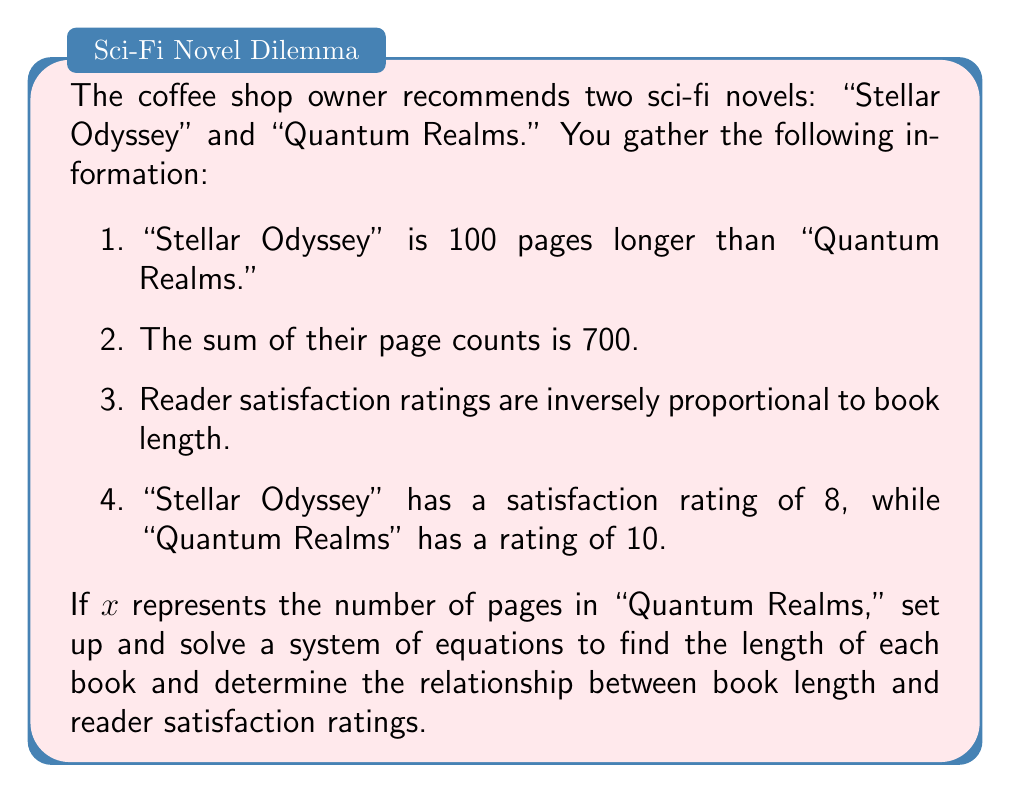Solve this math problem. Let's approach this step-by-step:

1) Let $x$ be the number of pages in "Quantum Realms" and $y$ be the number of pages in "Stellar Odyssey."

2) From the first condition, we can write:
   $y = x + 100$

3) From the second condition:
   $x + y = 700$

4) Substituting the expression for $y$ from step 2 into the equation from step 3:
   $x + (x + 100) = 700$
   $2x + 100 = 700$
   $2x = 600$
   $x = 300$

5) Now we can find $y$:
   $y = x + 100 = 300 + 100 = 400$

6) To determine the relationship between book length and satisfaction rating, we can set up a proportion:
   
   For "Quantum Realms": $\frac{300}{10} = 30$
   For "Stellar Odyssey": $\frac{400}{8} = 50$

7) We can see that as the book length increases, the satisfaction rating decreases. To quantify this relationship, we can set up an equation:

   Let $R$ be the rating and $L$ be the length.
   $R \cdot L = k$ (constant)

8) Using the data for "Quantum Realms":
   $10 \cdot 300 = 3000 = k$

9) We can verify this with "Stellar Odyssey":
   $8 \cdot 400 = 3200 \approx 3000$

   The slight difference is due to rounding in the ratings.

Therefore, the relationship between book length $(L)$ and reader satisfaction rating $(R)$ can be approximated as:

$R = \frac{3000}{L}$

This inverse relationship shows that as book length increases, reader satisfaction tends to decrease, and vice versa.
Answer: "Quantum Realms": 300 pages, "Stellar Odyssey": 400 pages. Relationship: $R \approx \frac{3000}{L}$, where $R$ is rating and $L$ is length. 